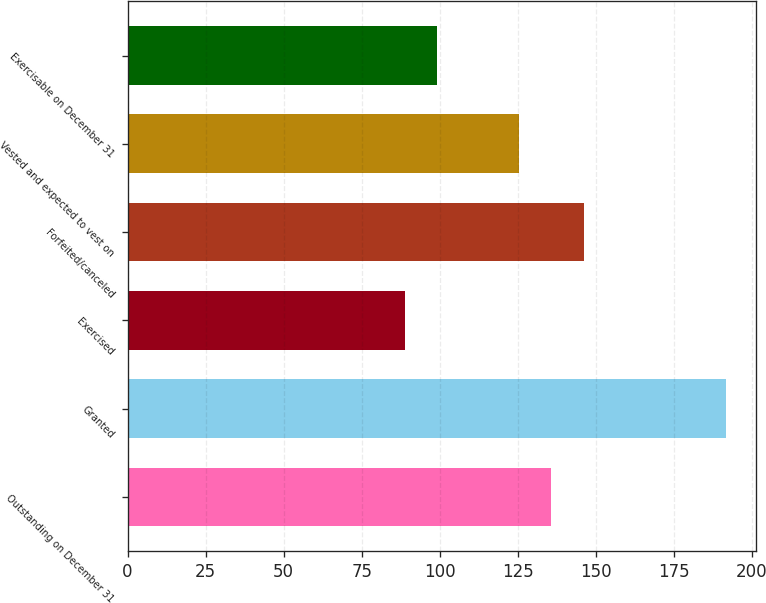Convert chart to OTSL. <chart><loc_0><loc_0><loc_500><loc_500><bar_chart><fcel>Outstanding on December 31<fcel>Granted<fcel>Exercised<fcel>Forfeited/canceled<fcel>Vested and expected to vest on<fcel>Exercisable on December 31<nl><fcel>135.76<fcel>191.84<fcel>88.75<fcel>146.07<fcel>125.45<fcel>99.06<nl></chart> 